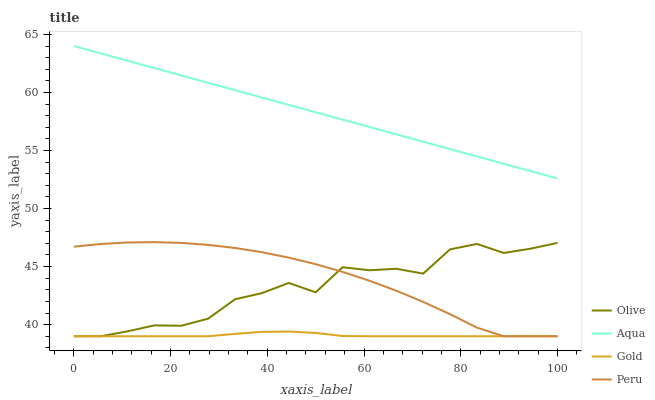Does Gold have the minimum area under the curve?
Answer yes or no. Yes. Does Aqua have the maximum area under the curve?
Answer yes or no. Yes. Does Peru have the minimum area under the curve?
Answer yes or no. No. Does Peru have the maximum area under the curve?
Answer yes or no. No. Is Aqua the smoothest?
Answer yes or no. Yes. Is Olive the roughest?
Answer yes or no. Yes. Is Peru the smoothest?
Answer yes or no. No. Is Peru the roughest?
Answer yes or no. No. Does Olive have the lowest value?
Answer yes or no. Yes. Does Aqua have the lowest value?
Answer yes or no. No. Does Aqua have the highest value?
Answer yes or no. Yes. Does Peru have the highest value?
Answer yes or no. No. Is Peru less than Aqua?
Answer yes or no. Yes. Is Aqua greater than Olive?
Answer yes or no. Yes. Does Olive intersect Peru?
Answer yes or no. Yes. Is Olive less than Peru?
Answer yes or no. No. Is Olive greater than Peru?
Answer yes or no. No. Does Peru intersect Aqua?
Answer yes or no. No. 